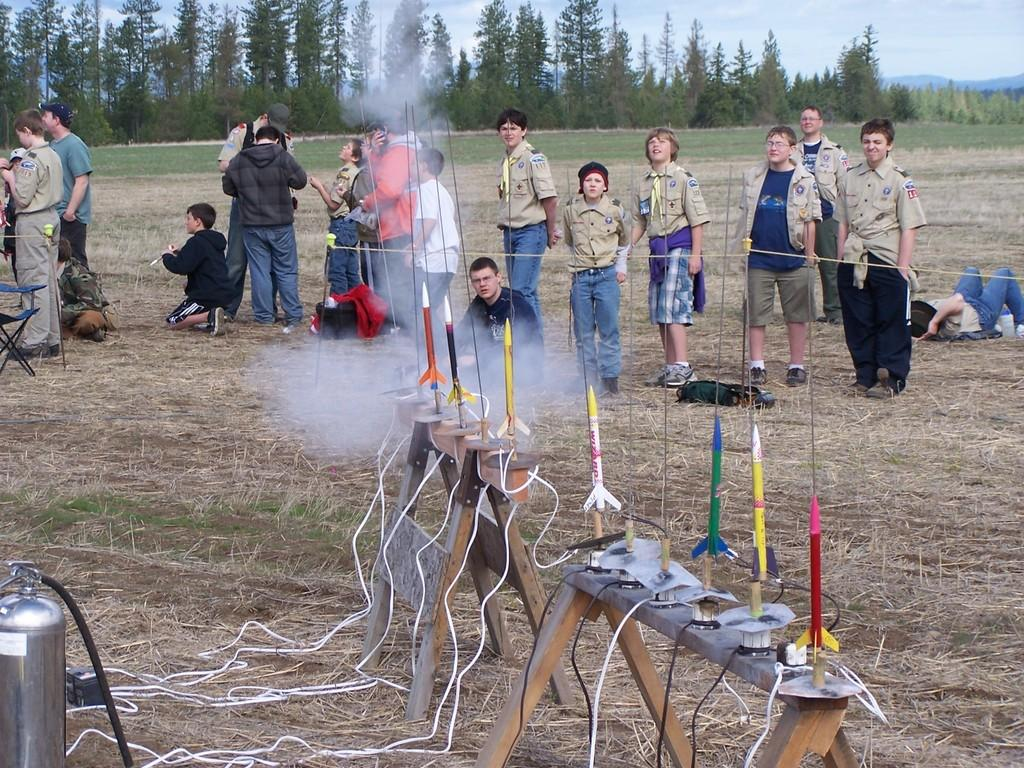How many people are in the image? There is a group of people in the image. What are the people in the image doing? Some people are standing, while others are sitting. What type of furniture is present in the image? There are chairs in the image. What type of toys can be seen in the image? Toy rockets are present in the image. What type of vegetation is visible in the image? There are trees in the image. What is visible in the background of the image? The sky with clouds is visible in the background of the image. What type of dress is the person wearing in the image? There is no specific dress mentioned in the provided facts, and the image does not show any person wearing a dress. How many books are visible in the image? There is no mention of books in the provided facts, and no books are visible in the image. 